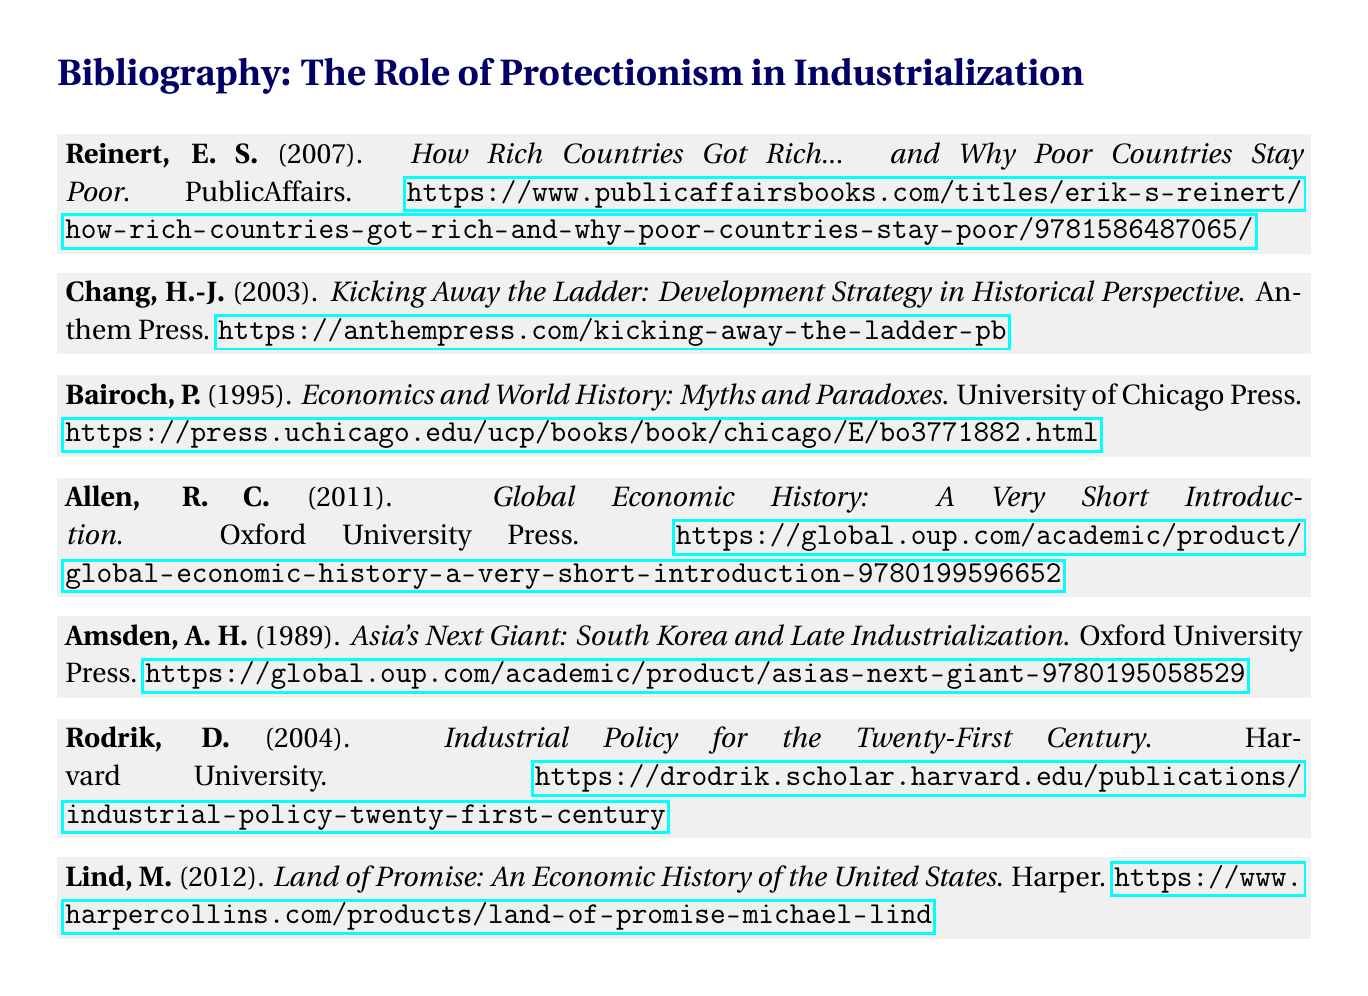What is the title of the first entry? The first entry’s title is specified immediately after the author and year.
Answer: How Rich Countries Got Rich... and Why Poor Countries Stay Poor Who is the author of "Kicking Away the Ladder"? The author name is listed before the title and the publication year in the bibliography entry.
Answer: H.-J. Chang What year was "Economics and World History: Myths and Paradoxes" published? The publication year is given in parentheses right after the author’s name.
Answer: 1995 What publisher released "Asia's Next Giant: South Korea and Late Industrialization"? The publisher name comes after the title of the book in the bibliography.
Answer: Oxford University Press Which entry has the URL provided? The bibliography includes URLs for some entries at the end of the citations.
Answer: All entries Who authored "Industrial Policy for the Twenty-First Century"? The author's name appears directly before the title of the work.
Answer: D. Rodrik What is the total number of entries in the bibliography? The total number can be counted from the number of `\bibentry` commands in the document.
Answer: 6 What color is used for the section title? The color formatting for the section title is specified in the LaTeX document with a defined RGB value.
Answer: Dark blue What is the document type? The structure and formatting indicate that this is a bibliographic reference list.
Answer: Bibliography 